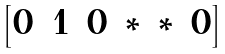<formula> <loc_0><loc_0><loc_500><loc_500>\begin{bmatrix} 0 & 1 & 0 & * & * & 0 \end{bmatrix}</formula> 